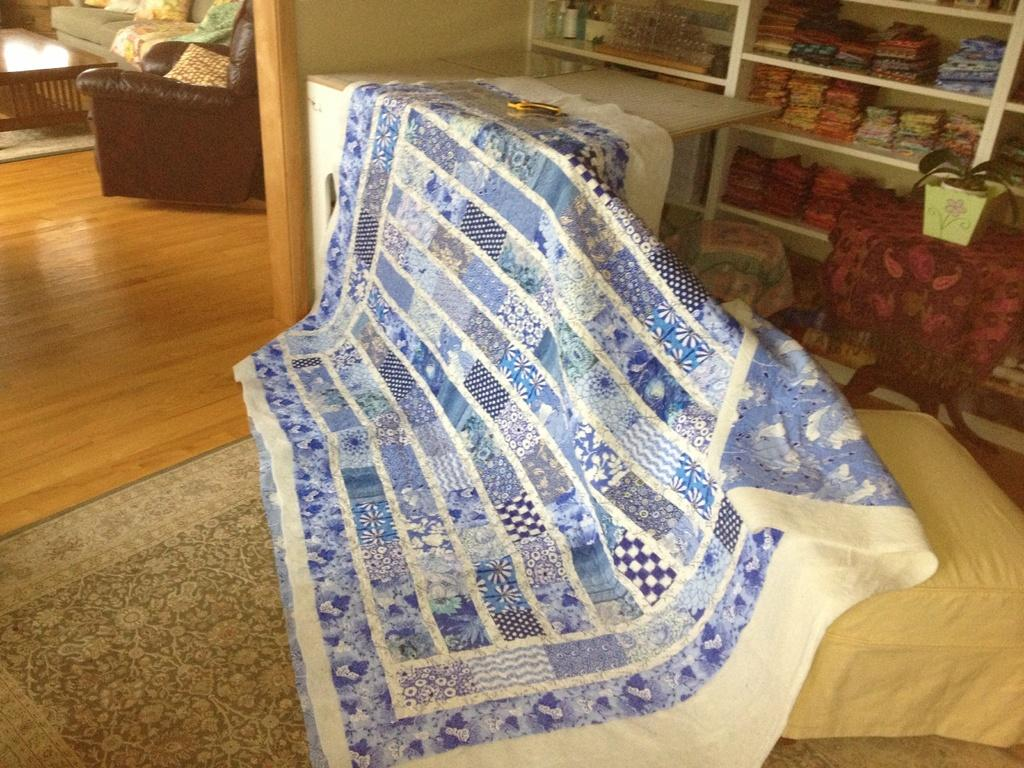What type of furniture is present in the room? There is a table and a sofa with pillows in the room. What can be found on the table in the room? There is a table near the sofa, but the facts do not specify what is on it. What is used for holding plants in the room? There is a flower pot with a plant in the room. What is used for storing clothes in the room? There are racks with clothes in the room. What part of the room can be seen? The floor is visible in the room. How many dolls are sitting on the sofa in the room? There is no mention of dolls in the room, so we cannot determine the number of dolls present. 